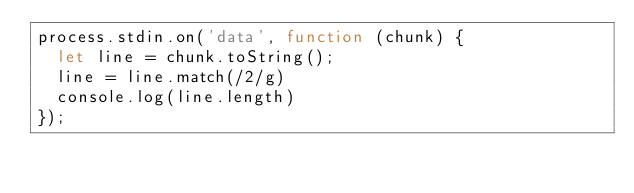<code> <loc_0><loc_0><loc_500><loc_500><_JavaScript_>process.stdin.on('data', function (chunk) {
  let line = chunk.toString();
  line = line.match(/2/g)
  console.log(line.length)
});</code> 